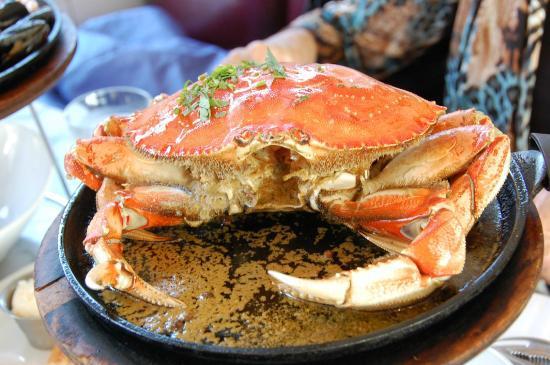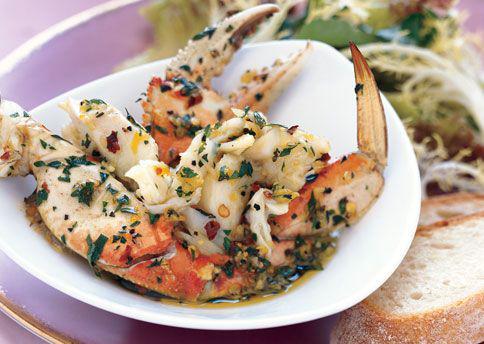The first image is the image on the left, the second image is the image on the right. Analyze the images presented: Is the assertion "One of the dishes is a whole crab." valid? Answer yes or no. Yes. 